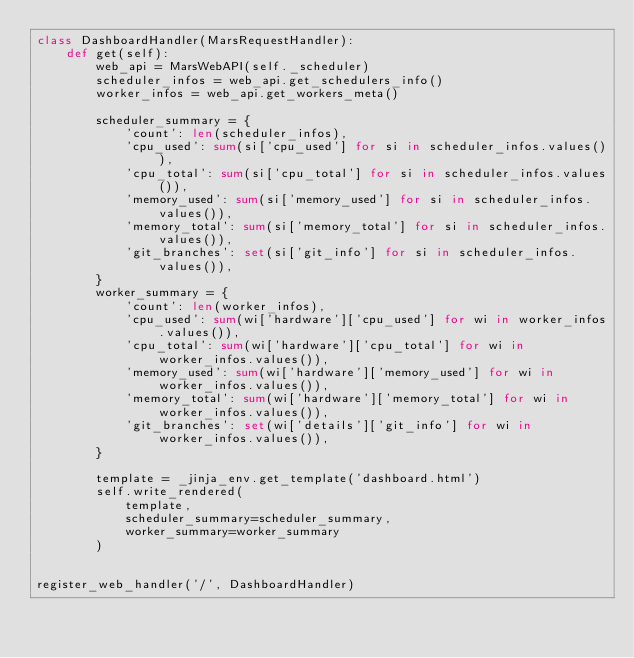Convert code to text. <code><loc_0><loc_0><loc_500><loc_500><_Python_>class DashboardHandler(MarsRequestHandler):
    def get(self):
        web_api = MarsWebAPI(self._scheduler)
        scheduler_infos = web_api.get_schedulers_info()
        worker_infos = web_api.get_workers_meta()

        scheduler_summary = {
            'count': len(scheduler_infos),
            'cpu_used': sum(si['cpu_used'] for si in scheduler_infos.values()),
            'cpu_total': sum(si['cpu_total'] for si in scheduler_infos.values()),
            'memory_used': sum(si['memory_used'] for si in scheduler_infos.values()),
            'memory_total': sum(si['memory_total'] for si in scheduler_infos.values()),
            'git_branches': set(si['git_info'] for si in scheduler_infos.values()),
        }
        worker_summary = {
            'count': len(worker_infos),
            'cpu_used': sum(wi['hardware']['cpu_used'] for wi in worker_infos.values()),
            'cpu_total': sum(wi['hardware']['cpu_total'] for wi in worker_infos.values()),
            'memory_used': sum(wi['hardware']['memory_used'] for wi in worker_infos.values()),
            'memory_total': sum(wi['hardware']['memory_total'] for wi in worker_infos.values()),
            'git_branches': set(wi['details']['git_info'] for wi in worker_infos.values()),
        }

        template = _jinja_env.get_template('dashboard.html')
        self.write_rendered(
            template,
            scheduler_summary=scheduler_summary,
            worker_summary=worker_summary
        )


register_web_handler('/', DashboardHandler)
</code> 